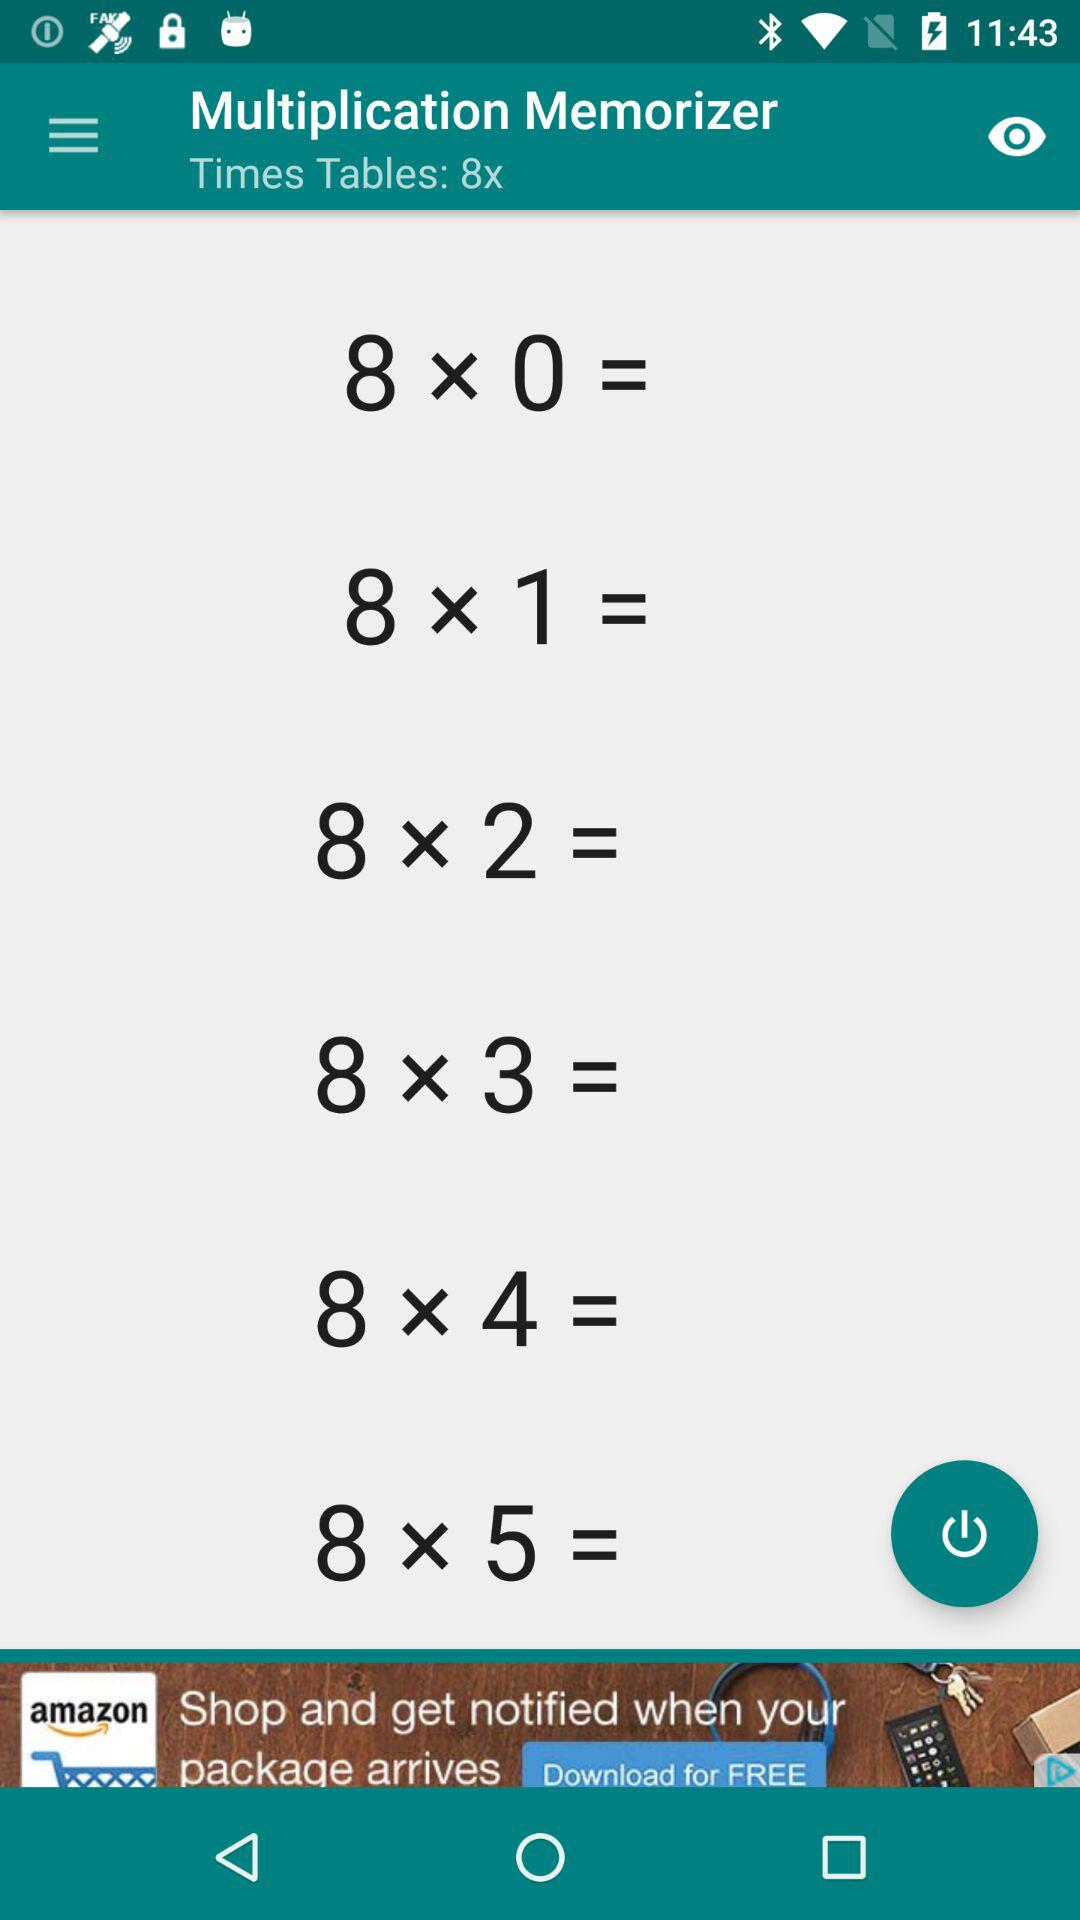What is the name of the application? The name of the application is "Multiplication Memorizer". 